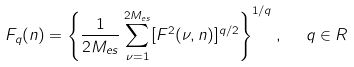<formula> <loc_0><loc_0><loc_500><loc_500>F _ { q } ( n ) = \left \{ \frac { 1 } { 2 M _ { e s } } \sum _ { \nu = 1 } ^ { 2 M _ { e s } } [ F ^ { 2 } ( \nu , n ) ] ^ { q / 2 } \right \} ^ { 1 / q } , \ \ q \in R</formula> 